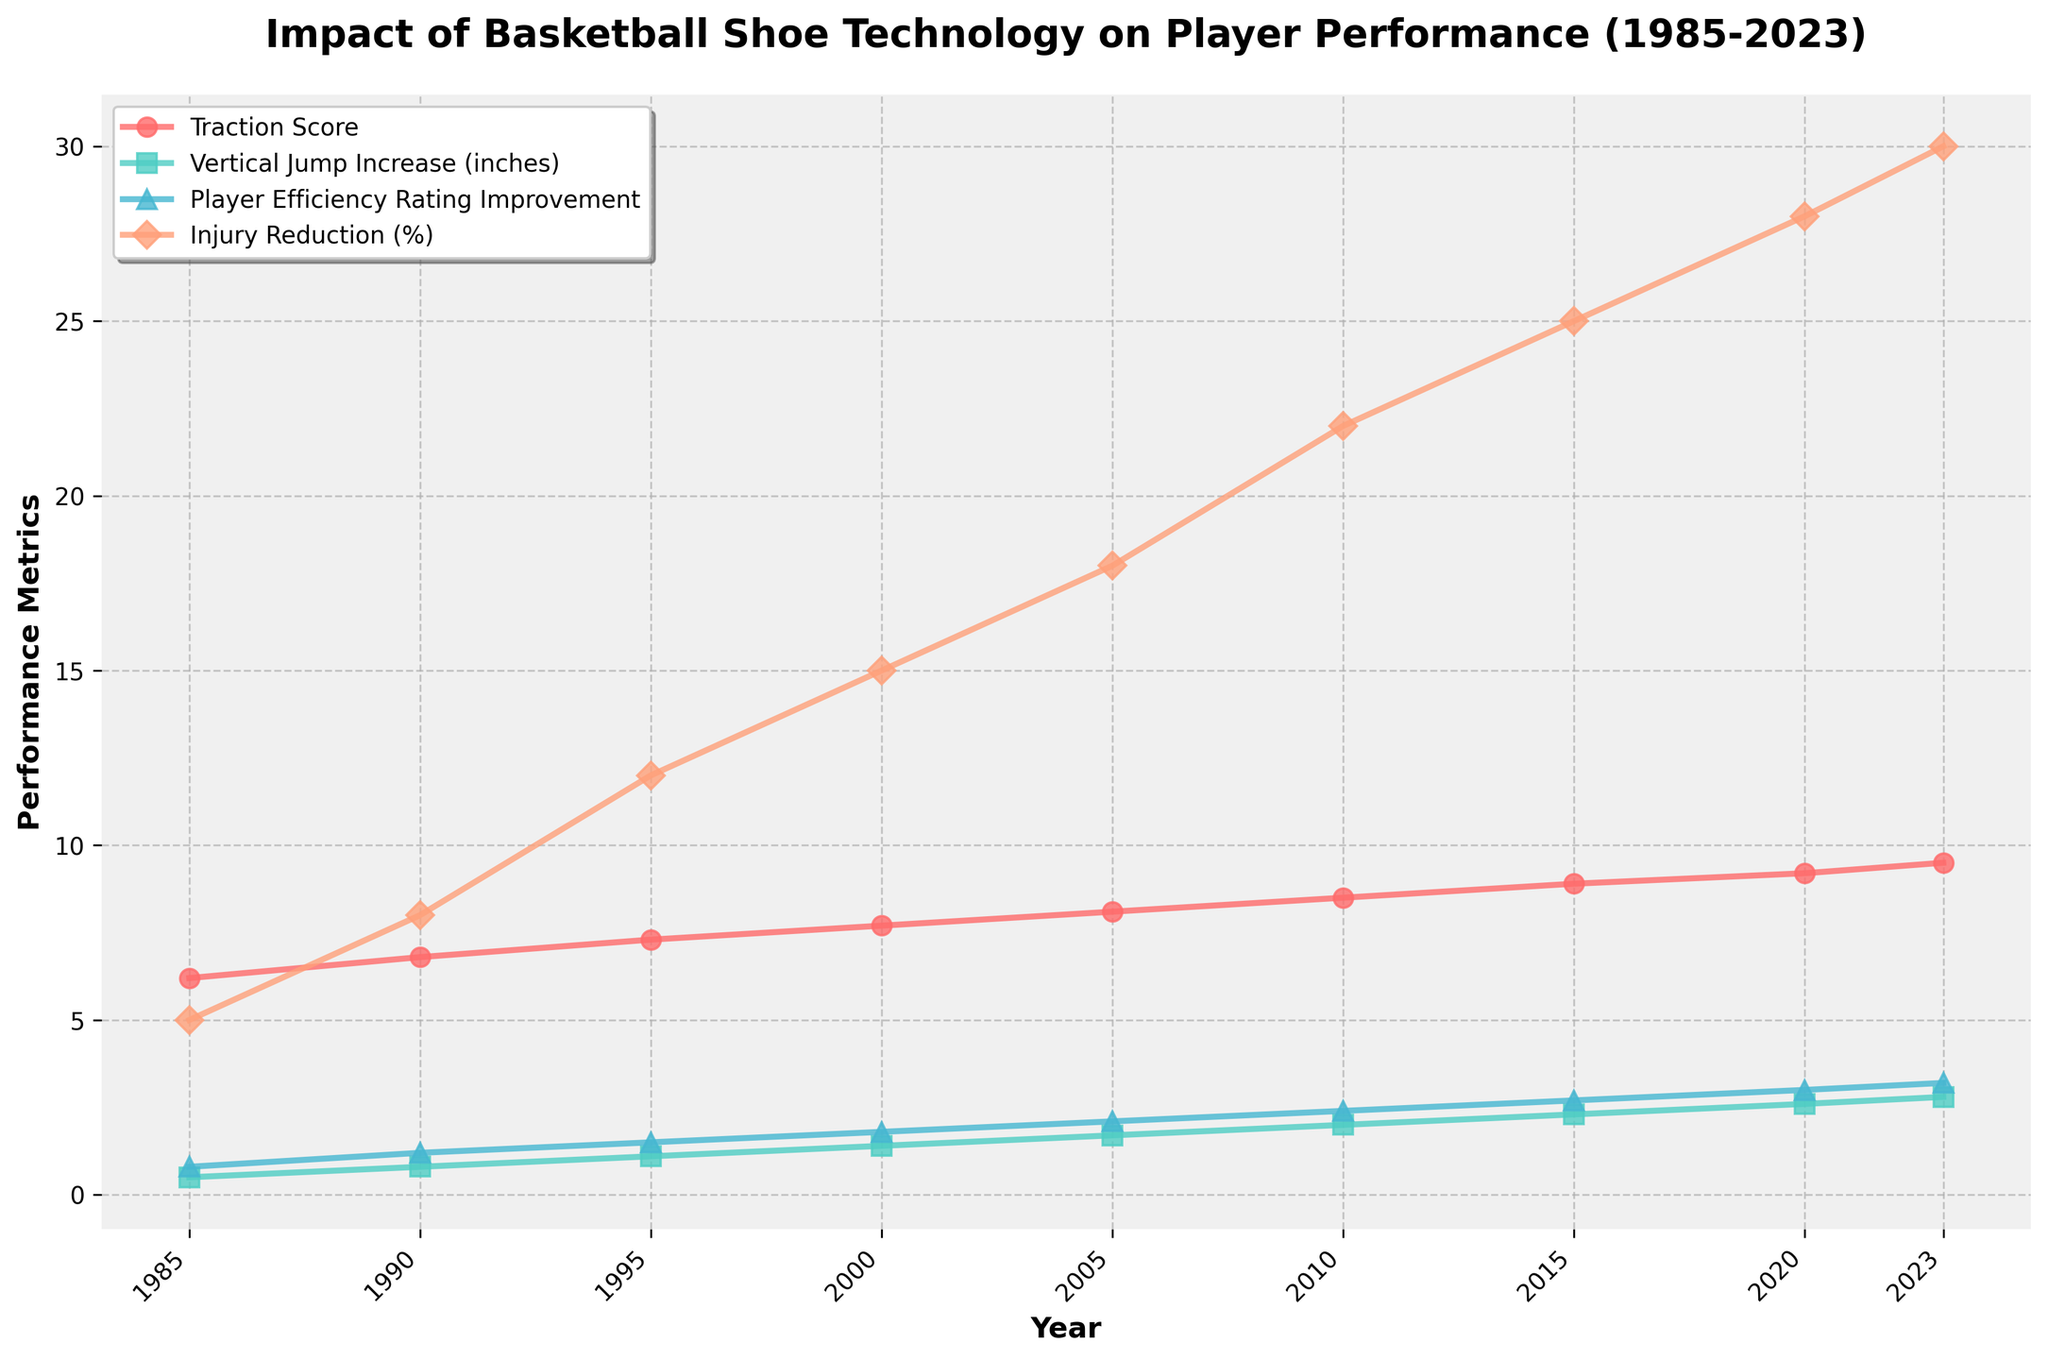What is the overall trend in the Traction Score from 1985 to 2023? The Traction Score line consistently rises from 1985 to 2023, indicating that traction has been improving over the years.
Answer: Increasing Which shoe technology corresponds to the highest Player Efficiency Rating Improvement in 2023? The vertical lines indicate Puma Nitro Foam in 2023, which shows the highest Player Efficiency Rating Improvement.
Answer: Puma Nitro Foam How much did the Vertical Jump Increase (inches) improve from 1985 to 2023? In 1985, the Vertical Jump Increase was 0.5 inches, and by 2023, it had risen to 2.8 inches. The improvement is 2.8 - 0.5.
Answer: 2.3 inches Which metric shows the most significant improvement in percentage terms from its 1985 value to its 2023 value? Injury Reduction (%) starts at 5% in 1985 and rises to 30% in 2023, showing the most significant improvement.
Answer: Injury Reduction (%) Compare the Traction Score of Adidas Torsion in 1995 to Nike Shox in 2005. Which is higher? In 1995, Adidas Torsion has a Traction Score of 7.3, while in 2005, Nike Shox has a Traction Score of 8.1. Nike Shox is higher.
Answer: Nike Shox What does the color green represent in the line chart? The color green represents the Vertical Jump Increase (inches) metric on the chart.
Answer: Vertical Jump Increase (inches) Between which two years did the Player Efficiency Rating Improvement see the most significant increase? The line for Player Efficiency Rating Improvement has the steepest slope between 2015 and 2020.
Answer: 2015-2020 What was the percentage change in Injury Reduction from 2000 to 2023? In 2000, Injury Reduction was 15%, and in 2023, it is 30%. The percentage change is ((30 - 15) / 15) * 100%.
Answer: 100% What visual change correlates with the improvement in cushioning technology from 1985 to 2023? The improvement in cushioning technology correlates with the ascending lines for Traction Score, Vertical Jump Increase, Player Efficiency Rating Improvement, and Injury Reduction.
Answer: Ascending lines What is the average Traction Score over the entire period? Summing the Traction Scores: 6.2 + 6.8 + 7.3 + 7.7 + 8.1 + 8.5 + 8.9 + 9.2 + 9.5 = 72.2. Dividing by 9 years gives 72.2 / 9.
Answer: 8.02 